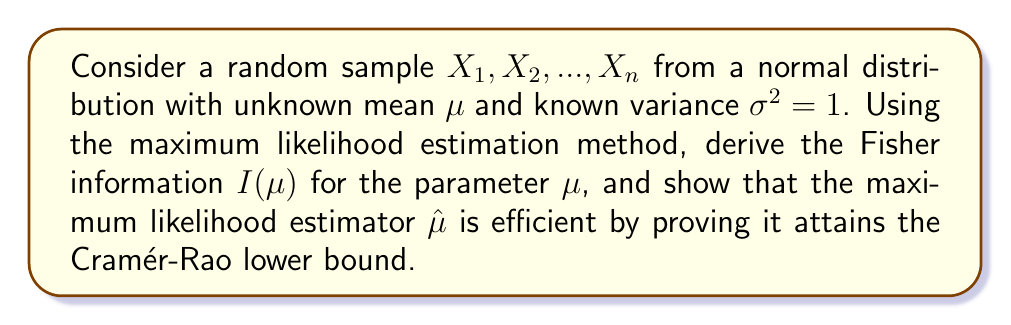Can you answer this question? Step 1: Write the likelihood function
The likelihood function for a normal distribution with known variance $\sigma^2 = 1$ is:
$$L(\mu) = \prod_{i=1}^n \frac{1}{\sqrt{2\pi}} e^{-\frac{(x_i - \mu)^2}{2}}$$

Step 2: Calculate the log-likelihood function
$$\ln L(\mu) = -\frac{n}{2}\ln(2\pi) - \frac{1}{2}\sum_{i=1}^n (x_i - \mu)^2$$

Step 3: Find the maximum likelihood estimator
Differentiate the log-likelihood with respect to $\mu$ and set it to zero:
$$\frac{\partial \ln L(\mu)}{\partial \mu} = \sum_{i=1}^n (x_i - \mu) = 0$$
Solving this equation gives the MLE:
$$\hat{\mu} = \frac{1}{n}\sum_{i=1}^n x_i$$

Step 4: Calculate the Fisher information
The Fisher information is given by:
$$I(\mu) = -E\left[\frac{\partial^2 \ln L(\mu)}{\partial \mu^2}\right]$$

Calculating the second derivative:
$$\frac{\partial^2 \ln L(\mu)}{\partial \mu^2} = -n$$

Therefore, the Fisher information is:
$$I(\mu) = n$$

Step 5: Calculate the variance of the MLE
The variance of $\hat{\mu}$ is:
$$Var(\hat{\mu}) = Var\left(\frac{1}{n}\sum_{i=1}^n X_i\right) = \frac{1}{n^2}\sum_{i=1}^n Var(X_i) = \frac{1}{n^2} \cdot n \cdot 1 = \frac{1}{n}$$

Step 6: Verify efficiency
The Cramér-Rao lower bound states that for any unbiased estimator, the variance is bounded below by the reciprocal of the Fisher information:
$$Var(\hat{\mu}) \geq \frac{1}{I(\mu)} = \frac{1}{n}$$

Since we found that $Var(\hat{\mu}) = \frac{1}{n}$, which equals the Cramér-Rao lower bound, we can conclude that $\hat{\mu}$ is an efficient estimator.
Answer: $I(\mu) = n$; $\hat{\mu}$ is efficient 